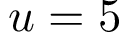<formula> <loc_0><loc_0><loc_500><loc_500>u = 5</formula> 